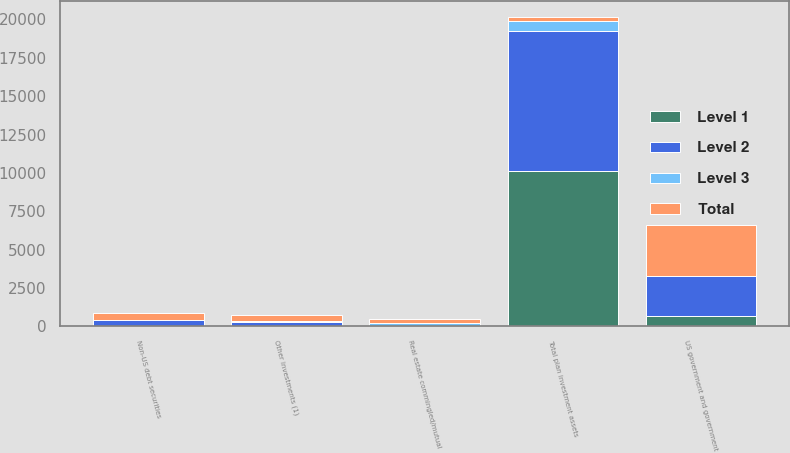Convert chart to OTSL. <chart><loc_0><loc_0><loc_500><loc_500><stacked_bar_chart><ecel><fcel>US government and government<fcel>Non-US debt securities<fcel>Real estate commingled/mutual<fcel>Other investments (1)<fcel>Total plan investment assets<nl><fcel>Level 1<fcel>701<fcel>36<fcel>30<fcel>19<fcel>10112<nl><fcel>Level 2<fcel>2604<fcel>397<fcel>2<fcel>258<fcel>9144<nl><fcel>Level 3<fcel>14<fcel>9<fcel>215<fcel>83<fcel>661<nl><fcel>Total<fcel>3319<fcel>442<fcel>247<fcel>360<fcel>258<nl></chart> 